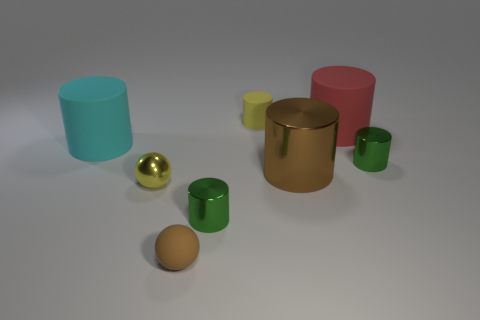Subtract all big brown cylinders. How many cylinders are left? 5 Add 2 tiny brown rubber spheres. How many objects exist? 10 Subtract all brown balls. How many balls are left? 1 Subtract all cyan cubes. How many green cylinders are left? 2 Subtract 1 balls. How many balls are left? 1 Subtract all blue spheres. Subtract all cyan cubes. How many spheres are left? 2 Add 4 small green rubber objects. How many small green rubber objects exist? 4 Subtract 0 red blocks. How many objects are left? 8 Subtract all cylinders. How many objects are left? 2 Subtract all green metallic objects. Subtract all big red matte cylinders. How many objects are left? 5 